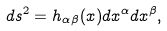<formula> <loc_0><loc_0><loc_500><loc_500>d s ^ { 2 } = h _ { \alpha \beta } ( x ) d x ^ { \alpha } d x ^ { \beta } ,</formula> 